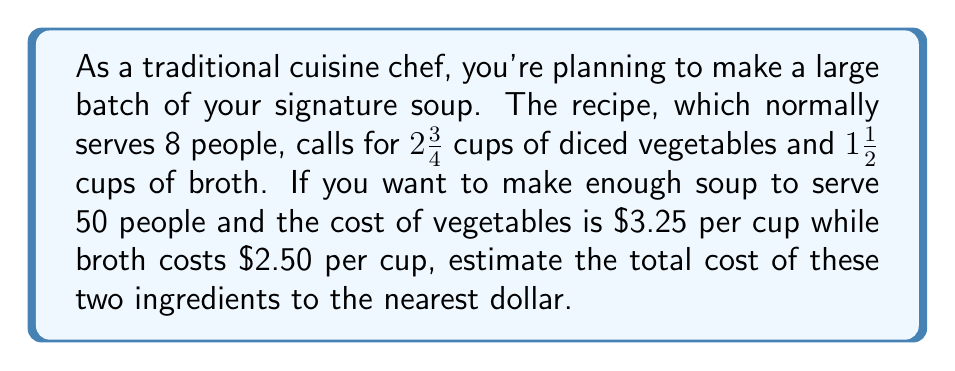Could you help me with this problem? Let's break this down step-by-step:

1) First, we need to calculate how much we need to scale up the recipe:
   $\frac{50 \text{ people}}{8 \text{ people}} = 6.25$

2) Now, let's calculate the new amounts of ingredients:
   Vegetables: $2\frac{3}{4} \times 6.25 = 2.75 \times 6.25 = 17.1875$ cups
   Broth: $1\frac{1}{2} \times 6.25 = 1.5 \times 6.25 = 9.375$ cups

3) Next, we calculate the cost of each ingredient:
   Vegetables: $17.1875 \times \$3.25 = \$55.859375$
   Broth: $9.375 \times \$2.50 = \$23.4375$

4) Now, we add these costs:
   $\$55.859375 + \$23.4375 = \$79.296875$

5) Finally, we round to the nearest dollar:
   $\$79.296875 \approx \$79$
Answer: $\$79$ 